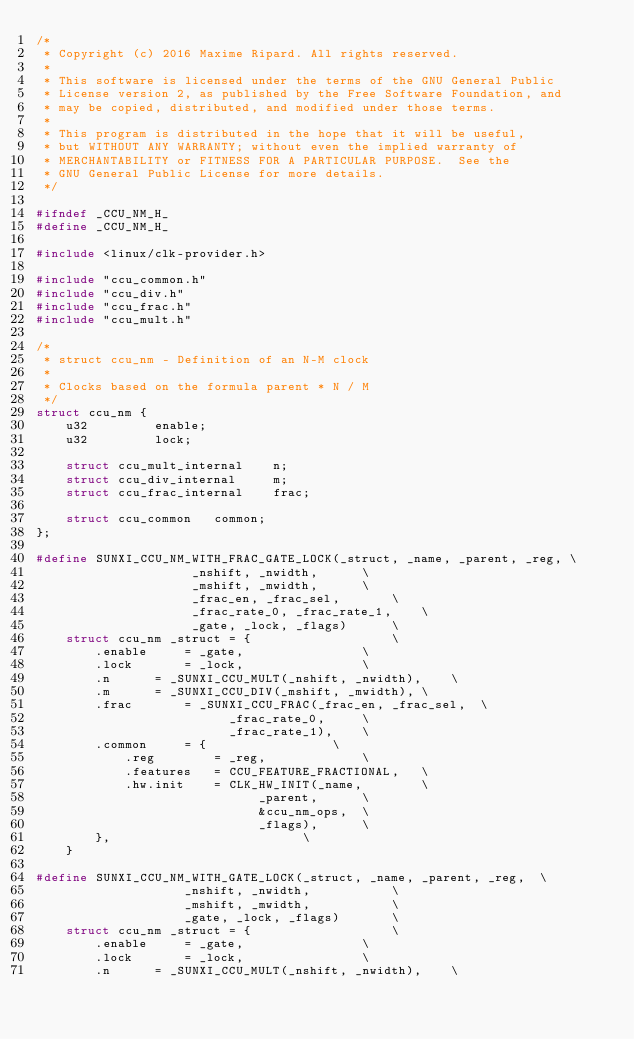Convert code to text. <code><loc_0><loc_0><loc_500><loc_500><_C_>/*
 * Copyright (c) 2016 Maxime Ripard. All rights reserved.
 *
 * This software is licensed under the terms of the GNU General Public
 * License version 2, as published by the Free Software Foundation, and
 * may be copied, distributed, and modified under those terms.
 *
 * This program is distributed in the hope that it will be useful,
 * but WITHOUT ANY WARRANTY; without even the implied warranty of
 * MERCHANTABILITY or FITNESS FOR A PARTICULAR PURPOSE.  See the
 * GNU General Public License for more details.
 */

#ifndef _CCU_NM_H_
#define _CCU_NM_H_

#include <linux/clk-provider.h>

#include "ccu_common.h"
#include "ccu_div.h"
#include "ccu_frac.h"
#include "ccu_mult.h"

/*
 * struct ccu_nm - Definition of an N-M clock
 *
 * Clocks based on the formula parent * N / M
 */
struct ccu_nm {
	u32			enable;
	u32			lock;

	struct ccu_mult_internal	n;
	struct ccu_div_internal		m;
	struct ccu_frac_internal	frac;

	struct ccu_common	common;
};

#define SUNXI_CCU_NM_WITH_FRAC_GATE_LOCK(_struct, _name, _parent, _reg,	\
					 _nshift, _nwidth,		\
					 _mshift, _mwidth,		\
					 _frac_en, _frac_sel,		\
					 _frac_rate_0, _frac_rate_1,	\
					 _gate, _lock, _flags)		\
	struct ccu_nm _struct = {					\
		.enable		= _gate,				\
		.lock		= _lock,				\
		.n		= _SUNXI_CCU_MULT(_nshift, _nwidth),	\
		.m		= _SUNXI_CCU_DIV(_mshift, _mwidth),	\
		.frac		= _SUNXI_CCU_FRAC(_frac_en, _frac_sel,	\
						  _frac_rate_0,		\
						  _frac_rate_1),	\
		.common		= {					\
			.reg		= _reg,				\
			.features	= CCU_FEATURE_FRACTIONAL,	\
			.hw.init	= CLK_HW_INIT(_name,		\
						      _parent,		\
						      &ccu_nm_ops,	\
						      _flags),		\
		},							\
	}

#define SUNXI_CCU_NM_WITH_GATE_LOCK(_struct, _name, _parent, _reg,	\
				    _nshift, _nwidth,			\
				    _mshift, _mwidth,			\
				    _gate, _lock, _flags)		\
	struct ccu_nm _struct = {					\
		.enable		= _gate,				\
		.lock		= _lock,				\
		.n		= _SUNXI_CCU_MULT(_nshift, _nwidth),	\</code> 